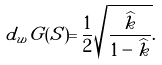<formula> <loc_0><loc_0><loc_500><loc_500>d _ { w } G ( S ) = \frac { 1 } { 2 } \sqrt { \frac { \widehat { k } } { 1 - \widehat { k } } } .</formula> 